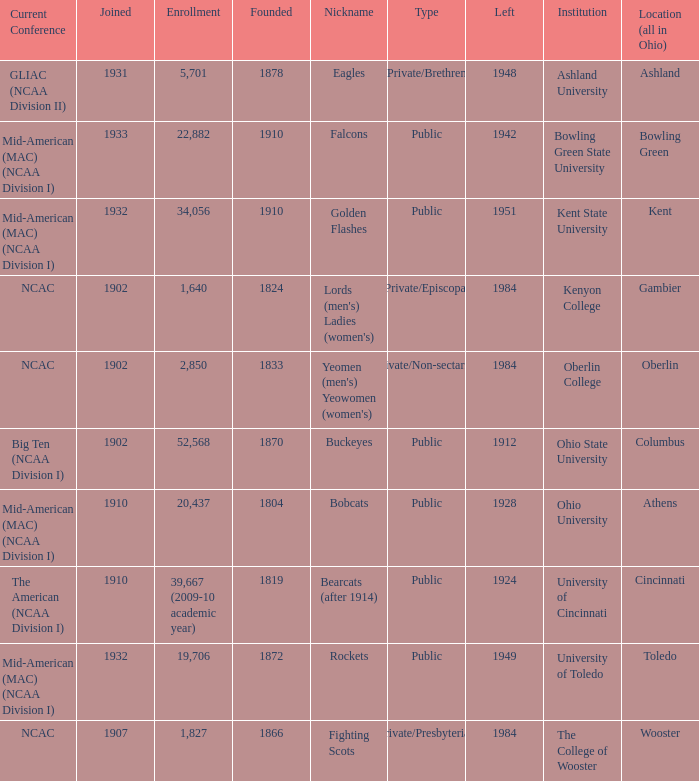Would you mind parsing the complete table? {'header': ['Current Conference', 'Joined', 'Enrollment', 'Founded', 'Nickname', 'Type', 'Left', 'Institution', 'Location (all in Ohio)'], 'rows': [['GLIAC (NCAA Division II)', '1931', '5,701', '1878', 'Eagles', 'Private/Brethren', '1948', 'Ashland University', 'Ashland'], ['Mid-American (MAC) (NCAA Division I)', '1933', '22,882', '1910', 'Falcons', 'Public', '1942', 'Bowling Green State University', 'Bowling Green'], ['Mid-American (MAC) (NCAA Division I)', '1932', '34,056', '1910', 'Golden Flashes', 'Public', '1951', 'Kent State University', 'Kent'], ['NCAC', '1902', '1,640', '1824', "Lords (men's) Ladies (women's)", 'Private/Episcopal', '1984', 'Kenyon College', 'Gambier'], ['NCAC', '1902', '2,850', '1833', "Yeomen (men's) Yeowomen (women's)", 'Private/Non-sectarian', '1984', 'Oberlin College', 'Oberlin'], ['Big Ten (NCAA Division I)', '1902', '52,568', '1870', 'Buckeyes', 'Public', '1912', 'Ohio State University', 'Columbus'], ['Mid-American (MAC) (NCAA Division I)', '1910', '20,437', '1804', 'Bobcats', 'Public', '1928', 'Ohio University', 'Athens'], ['The American (NCAA Division I)', '1910', '39,667 (2009-10 academic year)', '1819', 'Bearcats (after 1914)', 'Public', '1924', 'University of Cincinnati', 'Cincinnati'], ['Mid-American (MAC) (NCAA Division I)', '1932', '19,706', '1872', 'Rockets', 'Public', '1949', 'University of Toledo', 'Toledo'], ['NCAC', '1907', '1,827', '1866', 'Fighting Scots', 'Private/Presbyterian', '1984', 'The College of Wooster', 'Wooster']]} Which year did enrolled Gambier members leave? 1984.0. 